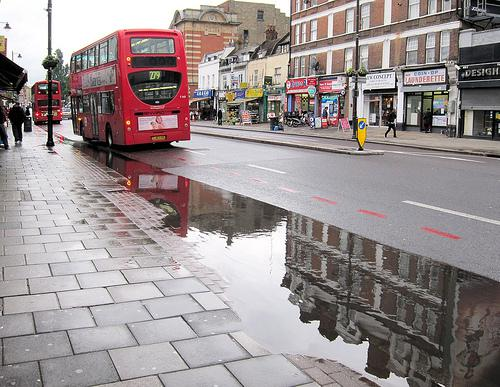Question: what type of vehicle is nearest the camera?
Choices:
A. Car.
B. Bike.
C. Scooter.
D. Bus.
Answer with the letter. Answer: D Question: what is the sidewalk made of?
Choices:
A. Stones.
B. Tile.
C. Wood.
D. Bricks.
Answer with the letter. Answer: A Question: why can you see a building on the street?
Choices:
A. A dog.
B. A cat.
C. A car.
D. Reflection in puddle.
Answer with the letter. Answer: D 